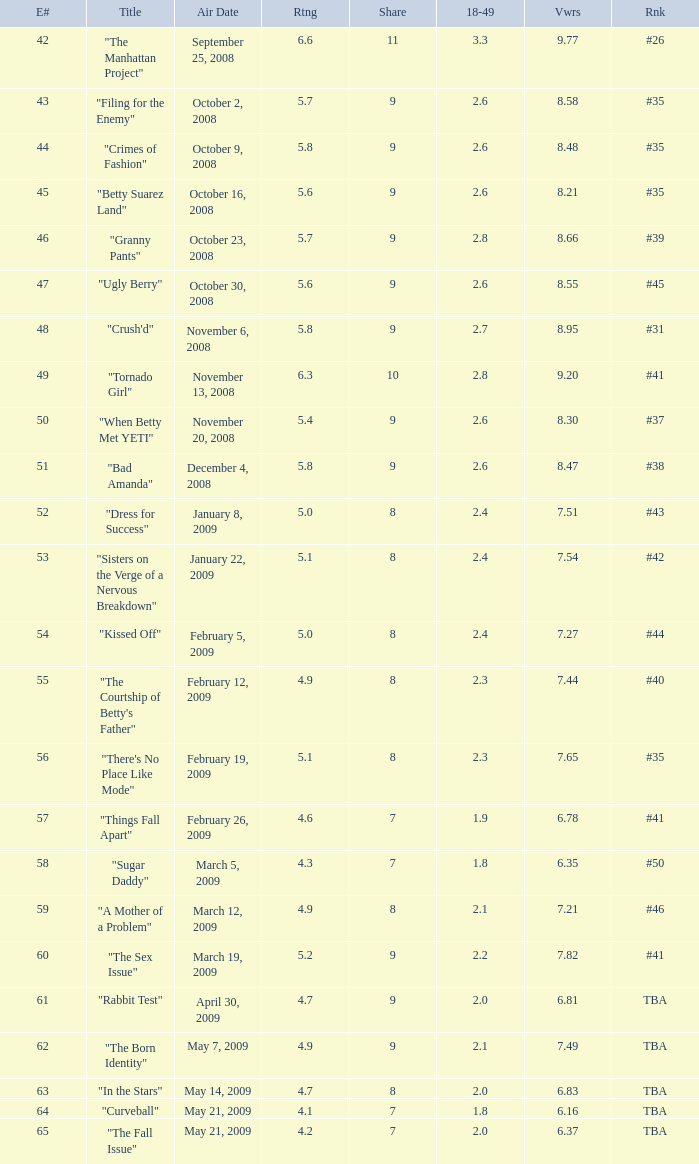What is the Air Date that has a 18–49 larger than 1.9, less than 7.54 viewers and a rating less than 4.9? April 30, 2009, May 14, 2009, May 21, 2009. Parse the table in full. {'header': ['E#', 'Title', 'Air Date', 'Rtng', 'Share', '18-49', 'Vwrs', 'Rnk'], 'rows': [['42', '"The Manhattan Project"', 'September 25, 2008', '6.6', '11', '3.3', '9.77', '#26'], ['43', '"Filing for the Enemy"', 'October 2, 2008', '5.7', '9', '2.6', '8.58', '#35'], ['44', '"Crimes of Fashion"', 'October 9, 2008', '5.8', '9', '2.6', '8.48', '#35'], ['45', '"Betty Suarez Land"', 'October 16, 2008', '5.6', '9', '2.6', '8.21', '#35'], ['46', '"Granny Pants"', 'October 23, 2008', '5.7', '9', '2.8', '8.66', '#39'], ['47', '"Ugly Berry"', 'October 30, 2008', '5.6', '9', '2.6', '8.55', '#45'], ['48', '"Crush\'d"', 'November 6, 2008', '5.8', '9', '2.7', '8.95', '#31'], ['49', '"Tornado Girl"', 'November 13, 2008', '6.3', '10', '2.8', '9.20', '#41'], ['50', '"When Betty Met YETI"', 'November 20, 2008', '5.4', '9', '2.6', '8.30', '#37'], ['51', '"Bad Amanda"', 'December 4, 2008', '5.8', '9', '2.6', '8.47', '#38'], ['52', '"Dress for Success"', 'January 8, 2009', '5.0', '8', '2.4', '7.51', '#43'], ['53', '"Sisters on the Verge of a Nervous Breakdown"', 'January 22, 2009', '5.1', '8', '2.4', '7.54', '#42'], ['54', '"Kissed Off"', 'February 5, 2009', '5.0', '8', '2.4', '7.27', '#44'], ['55', '"The Courtship of Betty\'s Father"', 'February 12, 2009', '4.9', '8', '2.3', '7.44', '#40'], ['56', '"There\'s No Place Like Mode"', 'February 19, 2009', '5.1', '8', '2.3', '7.65', '#35'], ['57', '"Things Fall Apart"', 'February 26, 2009', '4.6', '7', '1.9', '6.78', '#41'], ['58', '"Sugar Daddy"', 'March 5, 2009', '4.3', '7', '1.8', '6.35', '#50'], ['59', '"A Mother of a Problem"', 'March 12, 2009', '4.9', '8', '2.1', '7.21', '#46'], ['60', '"The Sex Issue"', 'March 19, 2009', '5.2', '9', '2.2', '7.82', '#41'], ['61', '"Rabbit Test"', 'April 30, 2009', '4.7', '9', '2.0', '6.81', 'TBA'], ['62', '"The Born Identity"', 'May 7, 2009', '4.9', '9', '2.1', '7.49', 'TBA'], ['63', '"In the Stars"', 'May 14, 2009', '4.7', '8', '2.0', '6.83', 'TBA'], ['64', '"Curveball"', 'May 21, 2009', '4.1', '7', '1.8', '6.16', 'TBA'], ['65', '"The Fall Issue"', 'May 21, 2009', '4.2', '7', '2.0', '6.37', 'TBA']]} 